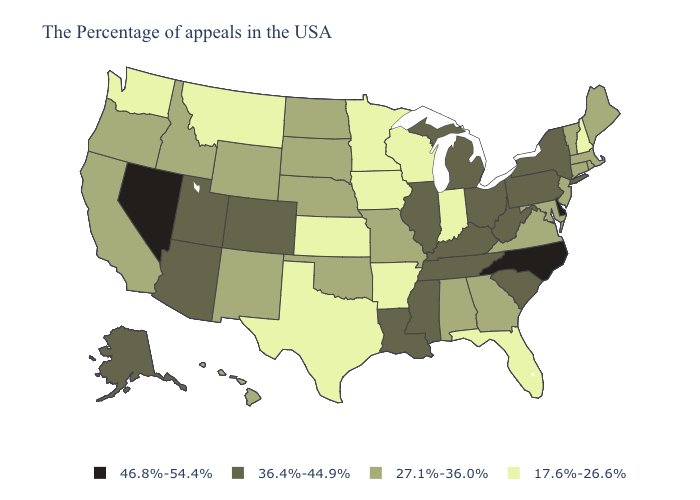What is the lowest value in states that border Nevada?
Be succinct. 27.1%-36.0%. Among the states that border Michigan , which have the lowest value?
Concise answer only. Indiana, Wisconsin. What is the value of Utah?
Short answer required. 36.4%-44.9%. Does Louisiana have the highest value in the USA?
Keep it brief. No. Among the states that border New Jersey , does Pennsylvania have the highest value?
Keep it brief. No. What is the value of Wyoming?
Short answer required. 27.1%-36.0%. What is the lowest value in the Northeast?
Concise answer only. 17.6%-26.6%. Does Rhode Island have a lower value than Ohio?
Short answer required. Yes. Does Michigan have the highest value in the MidWest?
Answer briefly. Yes. Name the states that have a value in the range 36.4%-44.9%?
Be succinct. New York, Pennsylvania, South Carolina, West Virginia, Ohio, Michigan, Kentucky, Tennessee, Illinois, Mississippi, Louisiana, Colorado, Utah, Arizona, Alaska. Name the states that have a value in the range 17.6%-26.6%?
Write a very short answer. New Hampshire, Florida, Indiana, Wisconsin, Arkansas, Minnesota, Iowa, Kansas, Texas, Montana, Washington. Name the states that have a value in the range 46.8%-54.4%?
Quick response, please. Delaware, North Carolina, Nevada. Among the states that border Alabama , which have the lowest value?
Be succinct. Florida. Among the states that border Utah , which have the highest value?
Write a very short answer. Nevada. What is the lowest value in the West?
Short answer required. 17.6%-26.6%. 